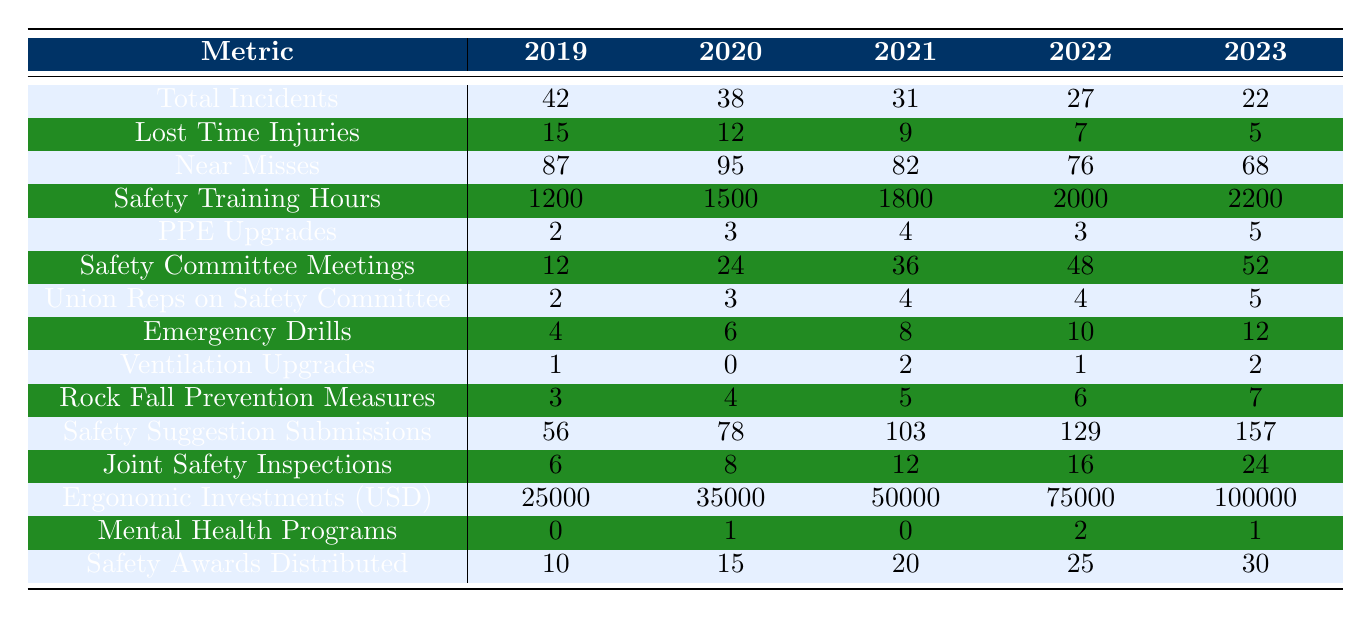What was the total number of incidents in 2022? In the table, the row for Total Incidents in the year 2022 shows the value 27.
Answer: 27 How many Lost Time Injuries were reported in 2020? The table indicates that Lost Time Injuries in 2020 were recorded as 12.
Answer: 12 What is the trend in Near Misses from 2019 to 2023? By examining the Near Misses row, we see the values decrease from 87 in 2019 to 68 in 2023, indicating a downward trend.
Answer: Decreasing trend How many Safety Awards were distributed in 2021? The table shows that 20 Safety Awards were distributed in 2021.
Answer: 20 What is the total number of Safety Committee Meetings held from 2019 to 2023? We sum the number of meetings over the years: 12 + 24 + 36 + 48 + 52 = 172.
Answer: 172 Did the number of Union Representatives on the Safety Committee increase from 2019 to 2023? In 2019, there were 2 Union Representatives and in 2023 there were 5, indicating an increase over the years.
Answer: Yes What was the percentage decrease in Lost Time Injuries from 2019 to 2023? The decrease in Lost Time Injuries from 15 in 2019 to 5 in 2023 is: (15 - 5) / 15 * 100 = 66.67%.
Answer: 66.67% What is the average number of Emergency Drills conducted per year from 2019 to 2023? To find the average, we sum the drills: 4 + 6 + 8 + 10 + 12 = 40, and then divide by 5 (the number of years), giving an average of 40 / 5 = 8.
Answer: 8 How many more Safety Suggestion Box submissions were received in 2023 compared to 2019? In 2023, there were 157 submissions and in 2019 there were 56, so the difference is 157 - 56 = 101.
Answer: 101 In which year was the highest investment in Ergonomic Equipment made? The table lists Ergonomic Equipment Investments; the highest value is 100,000 in 2023.
Answer: 2023 What is the difference in the number of Rock Fall Prevention Measures implemented between 2019 and 2023? The number of implemented measures increased from 3 in 2019 to 7 in 2023, resulting in a difference of 7 - 3 = 4.
Answer: 4 How many Joint Management-Union Safety Inspections were conducted in 2022? The table states that there were 16 Joint Safety Inspections conducted in 2022.
Answer: 16 Is there an increase in Mental Health Support Programs introduced from 2020 to 2023? In 2020 there was 1 program and in 2023 there were 1, indicating no increase.
Answer: No What were the total investments in Ergonomic Equipment from 2019 to 2023? The total investments are: 25000 + 35000 + 50000 + 75000 + 100000 = 250000.
Answer: 250000 How much did the Safety Training Hours increase from 2019 to 2023? Safety Training Hours increased from 1200 in 2019 to 2200 in 2023, a difference of 2200 - 1200 = 1000 hours.
Answer: 1000 hours 